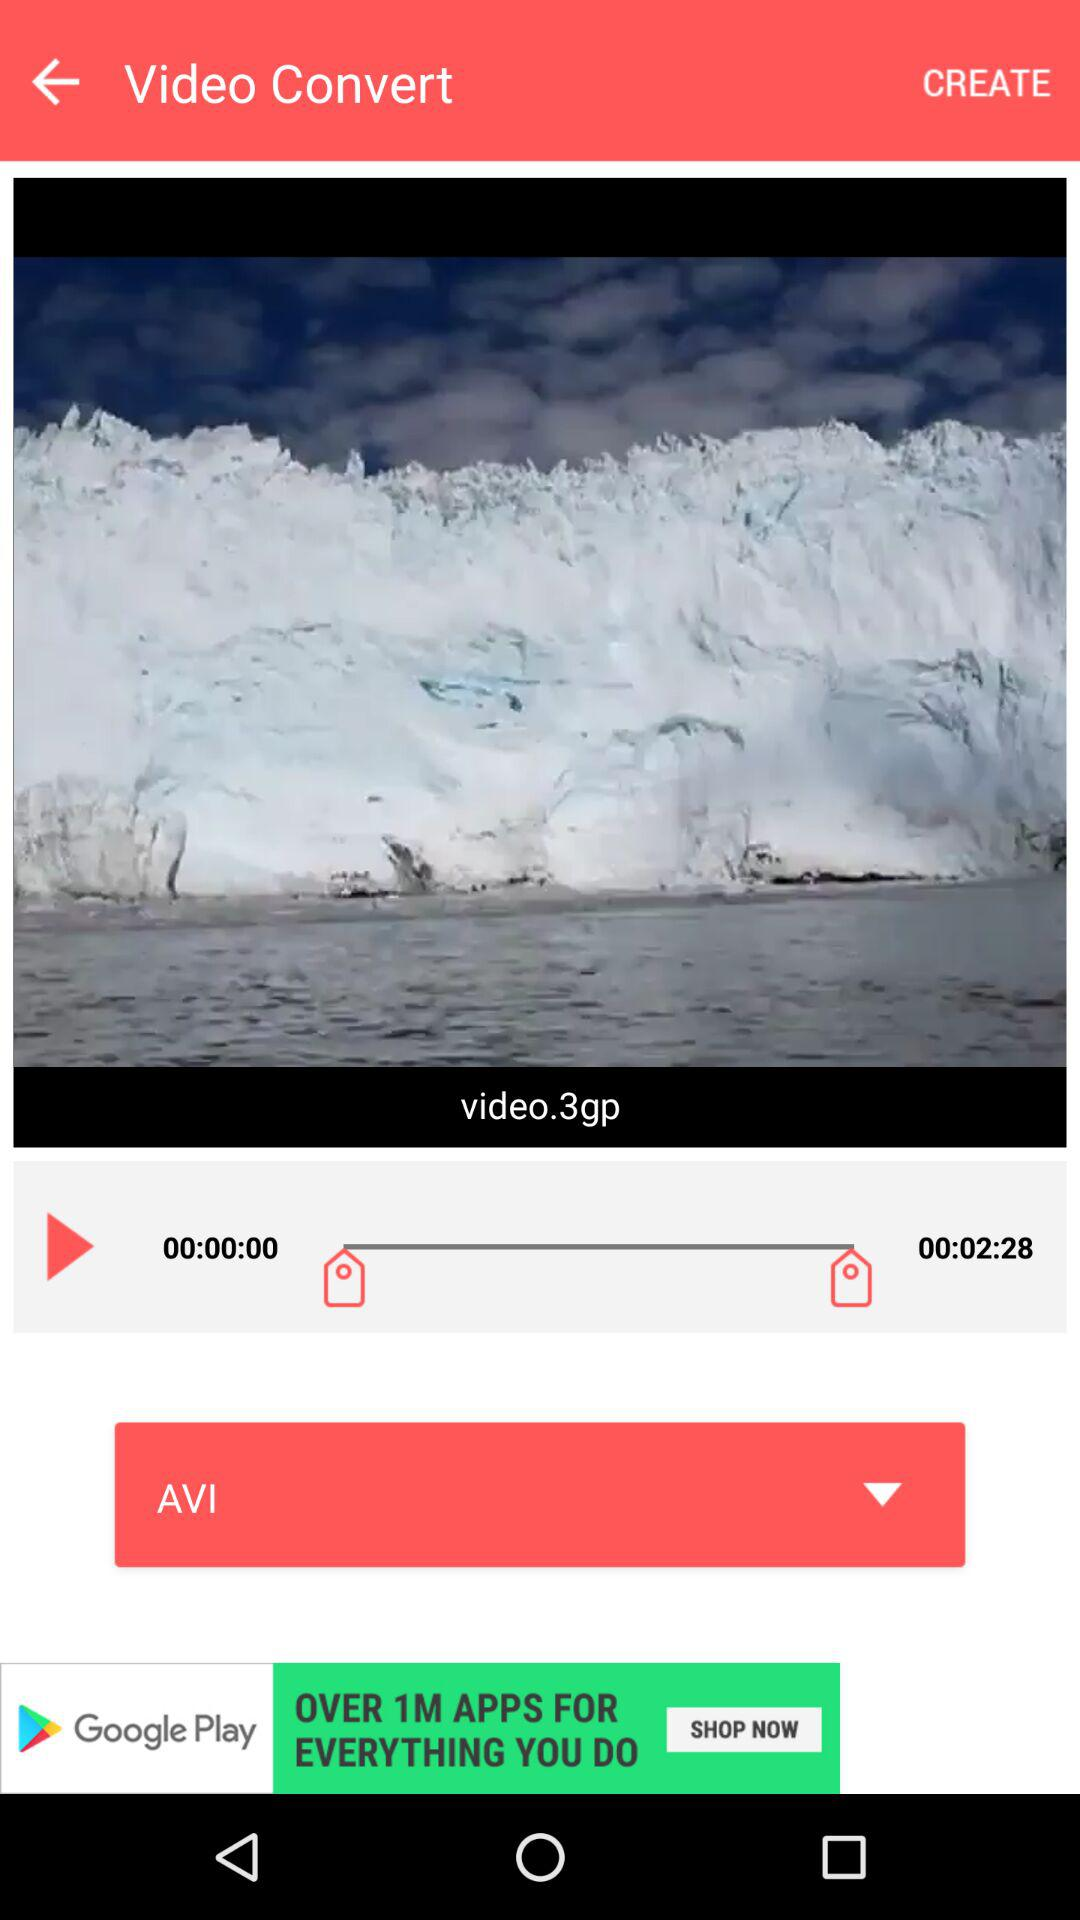What's the video name? The name of the video is "video.3gp". 